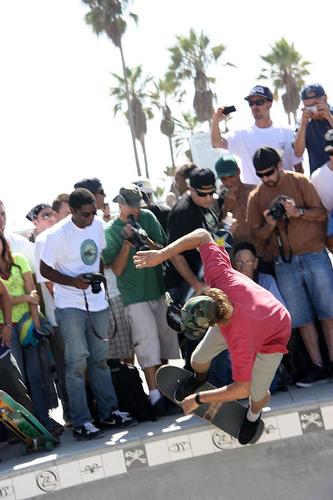Are all the people wearing sunglasses?
Write a very short answer. No. How many cameras are out?
Concise answer only. 5. What object is flying into the crowd?
Write a very short answer. Skateboard. What are these people doing?
Give a very brief answer. Skateboarding. 